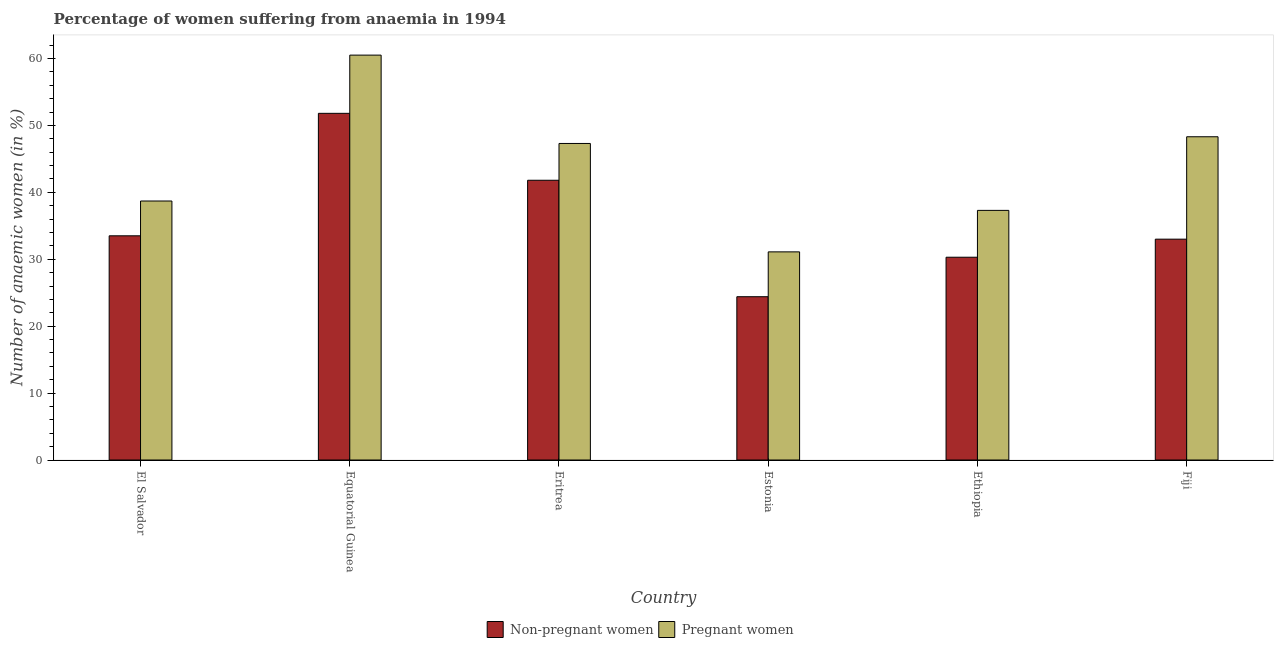How many different coloured bars are there?
Offer a very short reply. 2. How many groups of bars are there?
Provide a short and direct response. 6. How many bars are there on the 1st tick from the right?
Your response must be concise. 2. What is the label of the 6th group of bars from the left?
Your response must be concise. Fiji. In how many cases, is the number of bars for a given country not equal to the number of legend labels?
Provide a short and direct response. 0. What is the percentage of pregnant anaemic women in El Salvador?
Provide a succinct answer. 38.7. Across all countries, what is the maximum percentage of pregnant anaemic women?
Keep it short and to the point. 60.5. Across all countries, what is the minimum percentage of pregnant anaemic women?
Provide a succinct answer. 31.1. In which country was the percentage of pregnant anaemic women maximum?
Make the answer very short. Equatorial Guinea. In which country was the percentage of pregnant anaemic women minimum?
Your answer should be very brief. Estonia. What is the total percentage of non-pregnant anaemic women in the graph?
Provide a short and direct response. 214.8. What is the difference between the percentage of pregnant anaemic women in El Salvador and that in Eritrea?
Offer a terse response. -8.6. What is the difference between the percentage of pregnant anaemic women in El Salvador and the percentage of non-pregnant anaemic women in Eritrea?
Your answer should be compact. -3.1. What is the average percentage of non-pregnant anaemic women per country?
Ensure brevity in your answer.  35.8. What is the difference between the percentage of non-pregnant anaemic women and percentage of pregnant anaemic women in Fiji?
Your answer should be very brief. -15.3. In how many countries, is the percentage of non-pregnant anaemic women greater than 42 %?
Provide a succinct answer. 1. What is the ratio of the percentage of pregnant anaemic women in Eritrea to that in Ethiopia?
Offer a terse response. 1.27. Is the percentage of pregnant anaemic women in El Salvador less than that in Ethiopia?
Your answer should be compact. No. What is the difference between the highest and the second highest percentage of non-pregnant anaemic women?
Provide a short and direct response. 10. What is the difference between the highest and the lowest percentage of pregnant anaemic women?
Provide a short and direct response. 29.4. What does the 1st bar from the left in Ethiopia represents?
Give a very brief answer. Non-pregnant women. What does the 2nd bar from the right in Ethiopia represents?
Ensure brevity in your answer.  Non-pregnant women. What is the difference between two consecutive major ticks on the Y-axis?
Make the answer very short. 10. Are the values on the major ticks of Y-axis written in scientific E-notation?
Your response must be concise. No. Where does the legend appear in the graph?
Keep it short and to the point. Bottom center. What is the title of the graph?
Make the answer very short. Percentage of women suffering from anaemia in 1994. Does "Under-5(male)" appear as one of the legend labels in the graph?
Your answer should be very brief. No. What is the label or title of the X-axis?
Provide a short and direct response. Country. What is the label or title of the Y-axis?
Keep it short and to the point. Number of anaemic women (in %). What is the Number of anaemic women (in %) of Non-pregnant women in El Salvador?
Ensure brevity in your answer.  33.5. What is the Number of anaemic women (in %) of Pregnant women in El Salvador?
Your answer should be compact. 38.7. What is the Number of anaemic women (in %) of Non-pregnant women in Equatorial Guinea?
Offer a very short reply. 51.8. What is the Number of anaemic women (in %) of Pregnant women in Equatorial Guinea?
Ensure brevity in your answer.  60.5. What is the Number of anaemic women (in %) of Non-pregnant women in Eritrea?
Offer a terse response. 41.8. What is the Number of anaemic women (in %) of Pregnant women in Eritrea?
Your response must be concise. 47.3. What is the Number of anaemic women (in %) in Non-pregnant women in Estonia?
Provide a short and direct response. 24.4. What is the Number of anaemic women (in %) in Pregnant women in Estonia?
Your answer should be compact. 31.1. What is the Number of anaemic women (in %) in Non-pregnant women in Ethiopia?
Give a very brief answer. 30.3. What is the Number of anaemic women (in %) of Pregnant women in Ethiopia?
Your answer should be compact. 37.3. What is the Number of anaemic women (in %) in Pregnant women in Fiji?
Provide a succinct answer. 48.3. Across all countries, what is the maximum Number of anaemic women (in %) of Non-pregnant women?
Your response must be concise. 51.8. Across all countries, what is the maximum Number of anaemic women (in %) in Pregnant women?
Give a very brief answer. 60.5. Across all countries, what is the minimum Number of anaemic women (in %) in Non-pregnant women?
Keep it short and to the point. 24.4. Across all countries, what is the minimum Number of anaemic women (in %) of Pregnant women?
Offer a very short reply. 31.1. What is the total Number of anaemic women (in %) of Non-pregnant women in the graph?
Keep it short and to the point. 214.8. What is the total Number of anaemic women (in %) of Pregnant women in the graph?
Ensure brevity in your answer.  263.2. What is the difference between the Number of anaemic women (in %) of Non-pregnant women in El Salvador and that in Equatorial Guinea?
Give a very brief answer. -18.3. What is the difference between the Number of anaemic women (in %) of Pregnant women in El Salvador and that in Equatorial Guinea?
Your answer should be very brief. -21.8. What is the difference between the Number of anaemic women (in %) of Non-pregnant women in El Salvador and that in Eritrea?
Your answer should be compact. -8.3. What is the difference between the Number of anaemic women (in %) of Non-pregnant women in El Salvador and that in Estonia?
Offer a terse response. 9.1. What is the difference between the Number of anaemic women (in %) of Pregnant women in El Salvador and that in Ethiopia?
Ensure brevity in your answer.  1.4. What is the difference between the Number of anaemic women (in %) in Non-pregnant women in Equatorial Guinea and that in Estonia?
Your answer should be compact. 27.4. What is the difference between the Number of anaemic women (in %) in Pregnant women in Equatorial Guinea and that in Estonia?
Provide a succinct answer. 29.4. What is the difference between the Number of anaemic women (in %) of Non-pregnant women in Equatorial Guinea and that in Ethiopia?
Offer a very short reply. 21.5. What is the difference between the Number of anaemic women (in %) in Pregnant women in Equatorial Guinea and that in Ethiopia?
Keep it short and to the point. 23.2. What is the difference between the Number of anaemic women (in %) of Pregnant women in Equatorial Guinea and that in Fiji?
Your answer should be compact. 12.2. What is the difference between the Number of anaemic women (in %) of Pregnant women in Eritrea and that in Estonia?
Keep it short and to the point. 16.2. What is the difference between the Number of anaemic women (in %) in Pregnant women in Eritrea and that in Ethiopia?
Make the answer very short. 10. What is the difference between the Number of anaemic women (in %) in Pregnant women in Eritrea and that in Fiji?
Your response must be concise. -1. What is the difference between the Number of anaemic women (in %) in Non-pregnant women in Estonia and that in Fiji?
Your answer should be very brief. -8.6. What is the difference between the Number of anaemic women (in %) of Pregnant women in Estonia and that in Fiji?
Your response must be concise. -17.2. What is the difference between the Number of anaemic women (in %) of Non-pregnant women in Ethiopia and that in Fiji?
Ensure brevity in your answer.  -2.7. What is the difference between the Number of anaemic women (in %) in Non-pregnant women in El Salvador and the Number of anaemic women (in %) in Pregnant women in Eritrea?
Ensure brevity in your answer.  -13.8. What is the difference between the Number of anaemic women (in %) of Non-pregnant women in El Salvador and the Number of anaemic women (in %) of Pregnant women in Ethiopia?
Your answer should be compact. -3.8. What is the difference between the Number of anaemic women (in %) in Non-pregnant women in El Salvador and the Number of anaemic women (in %) in Pregnant women in Fiji?
Your answer should be very brief. -14.8. What is the difference between the Number of anaemic women (in %) in Non-pregnant women in Equatorial Guinea and the Number of anaemic women (in %) in Pregnant women in Eritrea?
Provide a short and direct response. 4.5. What is the difference between the Number of anaemic women (in %) in Non-pregnant women in Equatorial Guinea and the Number of anaemic women (in %) in Pregnant women in Estonia?
Your response must be concise. 20.7. What is the difference between the Number of anaemic women (in %) of Non-pregnant women in Equatorial Guinea and the Number of anaemic women (in %) of Pregnant women in Ethiopia?
Provide a succinct answer. 14.5. What is the difference between the Number of anaemic women (in %) of Non-pregnant women in Equatorial Guinea and the Number of anaemic women (in %) of Pregnant women in Fiji?
Ensure brevity in your answer.  3.5. What is the difference between the Number of anaemic women (in %) of Non-pregnant women in Eritrea and the Number of anaemic women (in %) of Pregnant women in Estonia?
Keep it short and to the point. 10.7. What is the difference between the Number of anaemic women (in %) in Non-pregnant women in Eritrea and the Number of anaemic women (in %) in Pregnant women in Fiji?
Keep it short and to the point. -6.5. What is the difference between the Number of anaemic women (in %) of Non-pregnant women in Estonia and the Number of anaemic women (in %) of Pregnant women in Ethiopia?
Offer a very short reply. -12.9. What is the difference between the Number of anaemic women (in %) of Non-pregnant women in Estonia and the Number of anaemic women (in %) of Pregnant women in Fiji?
Give a very brief answer. -23.9. What is the average Number of anaemic women (in %) in Non-pregnant women per country?
Keep it short and to the point. 35.8. What is the average Number of anaemic women (in %) in Pregnant women per country?
Offer a terse response. 43.87. What is the difference between the Number of anaemic women (in %) of Non-pregnant women and Number of anaemic women (in %) of Pregnant women in Fiji?
Keep it short and to the point. -15.3. What is the ratio of the Number of anaemic women (in %) in Non-pregnant women in El Salvador to that in Equatorial Guinea?
Offer a terse response. 0.65. What is the ratio of the Number of anaemic women (in %) in Pregnant women in El Salvador to that in Equatorial Guinea?
Offer a very short reply. 0.64. What is the ratio of the Number of anaemic women (in %) of Non-pregnant women in El Salvador to that in Eritrea?
Provide a succinct answer. 0.8. What is the ratio of the Number of anaemic women (in %) in Pregnant women in El Salvador to that in Eritrea?
Your answer should be very brief. 0.82. What is the ratio of the Number of anaemic women (in %) of Non-pregnant women in El Salvador to that in Estonia?
Your response must be concise. 1.37. What is the ratio of the Number of anaemic women (in %) in Pregnant women in El Salvador to that in Estonia?
Your answer should be compact. 1.24. What is the ratio of the Number of anaemic women (in %) of Non-pregnant women in El Salvador to that in Ethiopia?
Your answer should be very brief. 1.11. What is the ratio of the Number of anaemic women (in %) of Pregnant women in El Salvador to that in Ethiopia?
Keep it short and to the point. 1.04. What is the ratio of the Number of anaemic women (in %) of Non-pregnant women in El Salvador to that in Fiji?
Your response must be concise. 1.02. What is the ratio of the Number of anaemic women (in %) in Pregnant women in El Salvador to that in Fiji?
Keep it short and to the point. 0.8. What is the ratio of the Number of anaemic women (in %) in Non-pregnant women in Equatorial Guinea to that in Eritrea?
Your response must be concise. 1.24. What is the ratio of the Number of anaemic women (in %) of Pregnant women in Equatorial Guinea to that in Eritrea?
Provide a short and direct response. 1.28. What is the ratio of the Number of anaemic women (in %) of Non-pregnant women in Equatorial Guinea to that in Estonia?
Your response must be concise. 2.12. What is the ratio of the Number of anaemic women (in %) in Pregnant women in Equatorial Guinea to that in Estonia?
Make the answer very short. 1.95. What is the ratio of the Number of anaemic women (in %) of Non-pregnant women in Equatorial Guinea to that in Ethiopia?
Offer a very short reply. 1.71. What is the ratio of the Number of anaemic women (in %) in Pregnant women in Equatorial Guinea to that in Ethiopia?
Keep it short and to the point. 1.62. What is the ratio of the Number of anaemic women (in %) of Non-pregnant women in Equatorial Guinea to that in Fiji?
Offer a very short reply. 1.57. What is the ratio of the Number of anaemic women (in %) of Pregnant women in Equatorial Guinea to that in Fiji?
Give a very brief answer. 1.25. What is the ratio of the Number of anaemic women (in %) in Non-pregnant women in Eritrea to that in Estonia?
Your answer should be compact. 1.71. What is the ratio of the Number of anaemic women (in %) in Pregnant women in Eritrea to that in Estonia?
Provide a short and direct response. 1.52. What is the ratio of the Number of anaemic women (in %) of Non-pregnant women in Eritrea to that in Ethiopia?
Offer a very short reply. 1.38. What is the ratio of the Number of anaemic women (in %) in Pregnant women in Eritrea to that in Ethiopia?
Provide a succinct answer. 1.27. What is the ratio of the Number of anaemic women (in %) of Non-pregnant women in Eritrea to that in Fiji?
Your answer should be very brief. 1.27. What is the ratio of the Number of anaemic women (in %) of Pregnant women in Eritrea to that in Fiji?
Ensure brevity in your answer.  0.98. What is the ratio of the Number of anaemic women (in %) of Non-pregnant women in Estonia to that in Ethiopia?
Give a very brief answer. 0.81. What is the ratio of the Number of anaemic women (in %) in Pregnant women in Estonia to that in Ethiopia?
Offer a very short reply. 0.83. What is the ratio of the Number of anaemic women (in %) of Non-pregnant women in Estonia to that in Fiji?
Ensure brevity in your answer.  0.74. What is the ratio of the Number of anaemic women (in %) in Pregnant women in Estonia to that in Fiji?
Your answer should be very brief. 0.64. What is the ratio of the Number of anaemic women (in %) in Non-pregnant women in Ethiopia to that in Fiji?
Keep it short and to the point. 0.92. What is the ratio of the Number of anaemic women (in %) of Pregnant women in Ethiopia to that in Fiji?
Ensure brevity in your answer.  0.77. What is the difference between the highest and the second highest Number of anaemic women (in %) in Non-pregnant women?
Provide a short and direct response. 10. What is the difference between the highest and the second highest Number of anaemic women (in %) of Pregnant women?
Offer a very short reply. 12.2. What is the difference between the highest and the lowest Number of anaemic women (in %) in Non-pregnant women?
Keep it short and to the point. 27.4. What is the difference between the highest and the lowest Number of anaemic women (in %) in Pregnant women?
Offer a terse response. 29.4. 